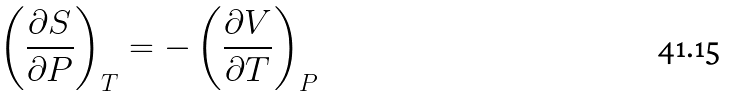Convert formula to latex. <formula><loc_0><loc_0><loc_500><loc_500>\left ( \frac { \partial S } { \partial P } \right ) _ { T } = - \left ( \frac { \partial V } { \partial T } \right ) _ { P }</formula> 